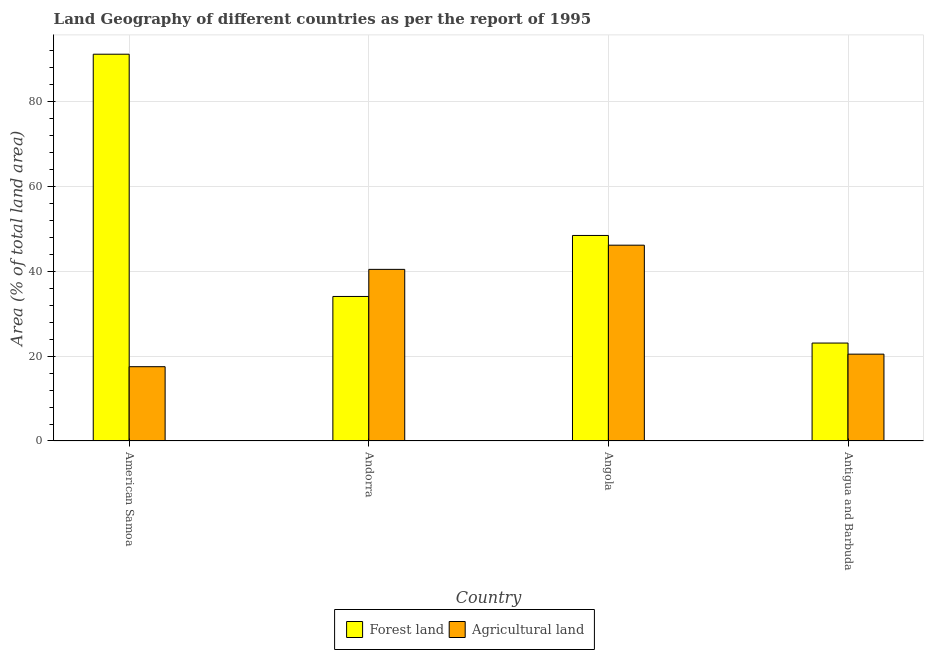How many groups of bars are there?
Keep it short and to the point. 4. Are the number of bars per tick equal to the number of legend labels?
Provide a succinct answer. Yes. How many bars are there on the 4th tick from the left?
Provide a short and direct response. 2. What is the label of the 3rd group of bars from the left?
Your answer should be compact. Angola. What is the percentage of land area under forests in Angola?
Provide a succinct answer. 48.41. Across all countries, what is the maximum percentage of land area under agriculture?
Keep it short and to the point. 46.12. Across all countries, what is the minimum percentage of land area under agriculture?
Make the answer very short. 17.5. In which country was the percentage of land area under forests maximum?
Your answer should be compact. American Samoa. In which country was the percentage of land area under forests minimum?
Offer a very short reply. Antigua and Barbuda. What is the total percentage of land area under agriculture in the graph?
Keep it short and to the point. 124.5. What is the difference between the percentage of land area under forests in Andorra and that in Angola?
Your response must be concise. -14.37. What is the difference between the percentage of land area under forests in Angola and the percentage of land area under agriculture in Andorra?
Provide a succinct answer. 7.98. What is the average percentage of land area under forests per country?
Your response must be concise. 49.16. What is the difference between the percentage of land area under agriculture and percentage of land area under forests in Andorra?
Give a very brief answer. 6.38. What is the ratio of the percentage of land area under agriculture in Andorra to that in Angola?
Offer a very short reply. 0.88. Is the difference between the percentage of land area under forests in Andorra and Angola greater than the difference between the percentage of land area under agriculture in Andorra and Angola?
Give a very brief answer. No. What is the difference between the highest and the second highest percentage of land area under forests?
Your answer should be compact. 42.69. What is the difference between the highest and the lowest percentage of land area under forests?
Your response must be concise. 68.03. In how many countries, is the percentage of land area under agriculture greater than the average percentage of land area under agriculture taken over all countries?
Your answer should be compact. 2. Is the sum of the percentage of land area under agriculture in American Samoa and Antigua and Barbuda greater than the maximum percentage of land area under forests across all countries?
Offer a terse response. No. What does the 1st bar from the left in Antigua and Barbuda represents?
Offer a terse response. Forest land. What does the 1st bar from the right in American Samoa represents?
Keep it short and to the point. Agricultural land. Are all the bars in the graph horizontal?
Offer a terse response. No. How many countries are there in the graph?
Provide a short and direct response. 4. What is the difference between two consecutive major ticks on the Y-axis?
Give a very brief answer. 20. Where does the legend appear in the graph?
Offer a very short reply. Bottom center. How many legend labels are there?
Make the answer very short. 2. What is the title of the graph?
Your response must be concise. Land Geography of different countries as per the report of 1995. What is the label or title of the Y-axis?
Make the answer very short. Area (% of total land area). What is the Area (% of total land area) of Forest land in American Samoa?
Make the answer very short. 91.1. What is the Area (% of total land area) of Forest land in Andorra?
Give a very brief answer. 34.04. What is the Area (% of total land area) in Agricultural land in Andorra?
Your answer should be very brief. 40.43. What is the Area (% of total land area) in Forest land in Angola?
Your answer should be compact. 48.41. What is the Area (% of total land area) of Agricultural land in Angola?
Provide a succinct answer. 46.12. What is the Area (% of total land area) in Forest land in Antigua and Barbuda?
Ensure brevity in your answer.  23.07. What is the Area (% of total land area) in Agricultural land in Antigua and Barbuda?
Offer a terse response. 20.45. Across all countries, what is the maximum Area (% of total land area) in Forest land?
Your answer should be compact. 91.1. Across all countries, what is the maximum Area (% of total land area) of Agricultural land?
Keep it short and to the point. 46.12. Across all countries, what is the minimum Area (% of total land area) of Forest land?
Ensure brevity in your answer.  23.07. Across all countries, what is the minimum Area (% of total land area) in Agricultural land?
Your answer should be very brief. 17.5. What is the total Area (% of total land area) of Forest land in the graph?
Keep it short and to the point. 196.62. What is the total Area (% of total land area) in Agricultural land in the graph?
Offer a terse response. 124.5. What is the difference between the Area (% of total land area) of Forest land in American Samoa and that in Andorra?
Your answer should be compact. 57.06. What is the difference between the Area (% of total land area) in Agricultural land in American Samoa and that in Andorra?
Ensure brevity in your answer.  -22.93. What is the difference between the Area (% of total land area) in Forest land in American Samoa and that in Angola?
Offer a very short reply. 42.69. What is the difference between the Area (% of total land area) in Agricultural land in American Samoa and that in Angola?
Keep it short and to the point. -28.62. What is the difference between the Area (% of total land area) in Forest land in American Samoa and that in Antigua and Barbuda?
Keep it short and to the point. 68.03. What is the difference between the Area (% of total land area) in Agricultural land in American Samoa and that in Antigua and Barbuda?
Offer a very short reply. -2.95. What is the difference between the Area (% of total land area) in Forest land in Andorra and that in Angola?
Give a very brief answer. -14.37. What is the difference between the Area (% of total land area) in Agricultural land in Andorra and that in Angola?
Ensure brevity in your answer.  -5.7. What is the difference between the Area (% of total land area) in Forest land in Andorra and that in Antigua and Barbuda?
Provide a short and direct response. 10.97. What is the difference between the Area (% of total land area) of Agricultural land in Andorra and that in Antigua and Barbuda?
Your response must be concise. 19.97. What is the difference between the Area (% of total land area) of Forest land in Angola and that in Antigua and Barbuda?
Your answer should be very brief. 25.34. What is the difference between the Area (% of total land area) of Agricultural land in Angola and that in Antigua and Barbuda?
Offer a very short reply. 25.67. What is the difference between the Area (% of total land area) of Forest land in American Samoa and the Area (% of total land area) of Agricultural land in Andorra?
Your response must be concise. 50.67. What is the difference between the Area (% of total land area) of Forest land in American Samoa and the Area (% of total land area) of Agricultural land in Angola?
Make the answer very short. 44.98. What is the difference between the Area (% of total land area) of Forest land in American Samoa and the Area (% of total land area) of Agricultural land in Antigua and Barbuda?
Give a very brief answer. 70.65. What is the difference between the Area (% of total land area) of Forest land in Andorra and the Area (% of total land area) of Agricultural land in Angola?
Offer a very short reply. -12.08. What is the difference between the Area (% of total land area) in Forest land in Andorra and the Area (% of total land area) in Agricultural land in Antigua and Barbuda?
Your response must be concise. 13.59. What is the difference between the Area (% of total land area) in Forest land in Angola and the Area (% of total land area) in Agricultural land in Antigua and Barbuda?
Offer a terse response. 27.95. What is the average Area (% of total land area) of Forest land per country?
Provide a succinct answer. 49.16. What is the average Area (% of total land area) in Agricultural land per country?
Make the answer very short. 31.13. What is the difference between the Area (% of total land area) in Forest land and Area (% of total land area) in Agricultural land in American Samoa?
Ensure brevity in your answer.  73.6. What is the difference between the Area (% of total land area) of Forest land and Area (% of total land area) of Agricultural land in Andorra?
Provide a short and direct response. -6.38. What is the difference between the Area (% of total land area) in Forest land and Area (% of total land area) in Agricultural land in Angola?
Provide a succinct answer. 2.29. What is the difference between the Area (% of total land area) of Forest land and Area (% of total land area) of Agricultural land in Antigua and Barbuda?
Offer a terse response. 2.61. What is the ratio of the Area (% of total land area) in Forest land in American Samoa to that in Andorra?
Make the answer very short. 2.68. What is the ratio of the Area (% of total land area) of Agricultural land in American Samoa to that in Andorra?
Offer a very short reply. 0.43. What is the ratio of the Area (% of total land area) in Forest land in American Samoa to that in Angola?
Keep it short and to the point. 1.88. What is the ratio of the Area (% of total land area) of Agricultural land in American Samoa to that in Angola?
Make the answer very short. 0.38. What is the ratio of the Area (% of total land area) in Forest land in American Samoa to that in Antigua and Barbuda?
Provide a short and direct response. 3.95. What is the ratio of the Area (% of total land area) in Agricultural land in American Samoa to that in Antigua and Barbuda?
Your answer should be compact. 0.86. What is the ratio of the Area (% of total land area) in Forest land in Andorra to that in Angola?
Offer a very short reply. 0.7. What is the ratio of the Area (% of total land area) of Agricultural land in Andorra to that in Angola?
Give a very brief answer. 0.88. What is the ratio of the Area (% of total land area) in Forest land in Andorra to that in Antigua and Barbuda?
Make the answer very short. 1.48. What is the ratio of the Area (% of total land area) of Agricultural land in Andorra to that in Antigua and Barbuda?
Provide a succinct answer. 1.98. What is the ratio of the Area (% of total land area) in Forest land in Angola to that in Antigua and Barbuda?
Give a very brief answer. 2.1. What is the ratio of the Area (% of total land area) of Agricultural land in Angola to that in Antigua and Barbuda?
Your answer should be very brief. 2.25. What is the difference between the highest and the second highest Area (% of total land area) of Forest land?
Offer a very short reply. 42.69. What is the difference between the highest and the second highest Area (% of total land area) of Agricultural land?
Ensure brevity in your answer.  5.7. What is the difference between the highest and the lowest Area (% of total land area) of Forest land?
Ensure brevity in your answer.  68.03. What is the difference between the highest and the lowest Area (% of total land area) of Agricultural land?
Keep it short and to the point. 28.62. 